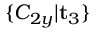Convert formula to latex. <formula><loc_0><loc_0><loc_500><loc_500>\{ C _ { 2 y } | t _ { 3 } \}</formula> 